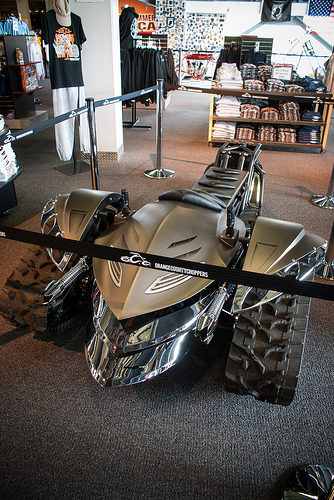<image>
Is the car behind the rope barricade? Yes. From this viewpoint, the car is positioned behind the rope barricade, with the rope barricade partially or fully occluding the car. 